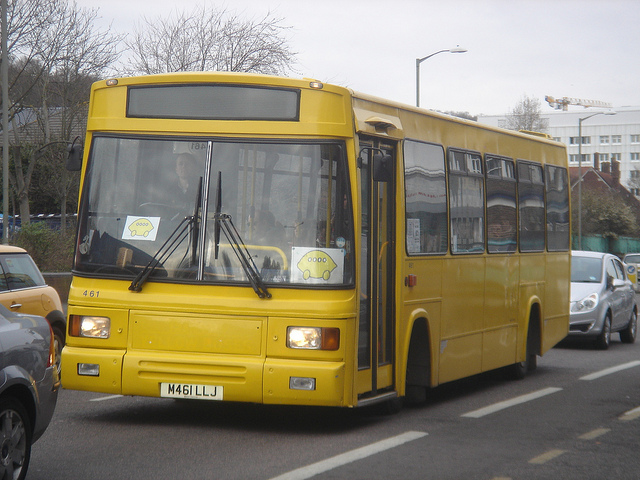Read all the text in this image. 461 M461 LLJ 